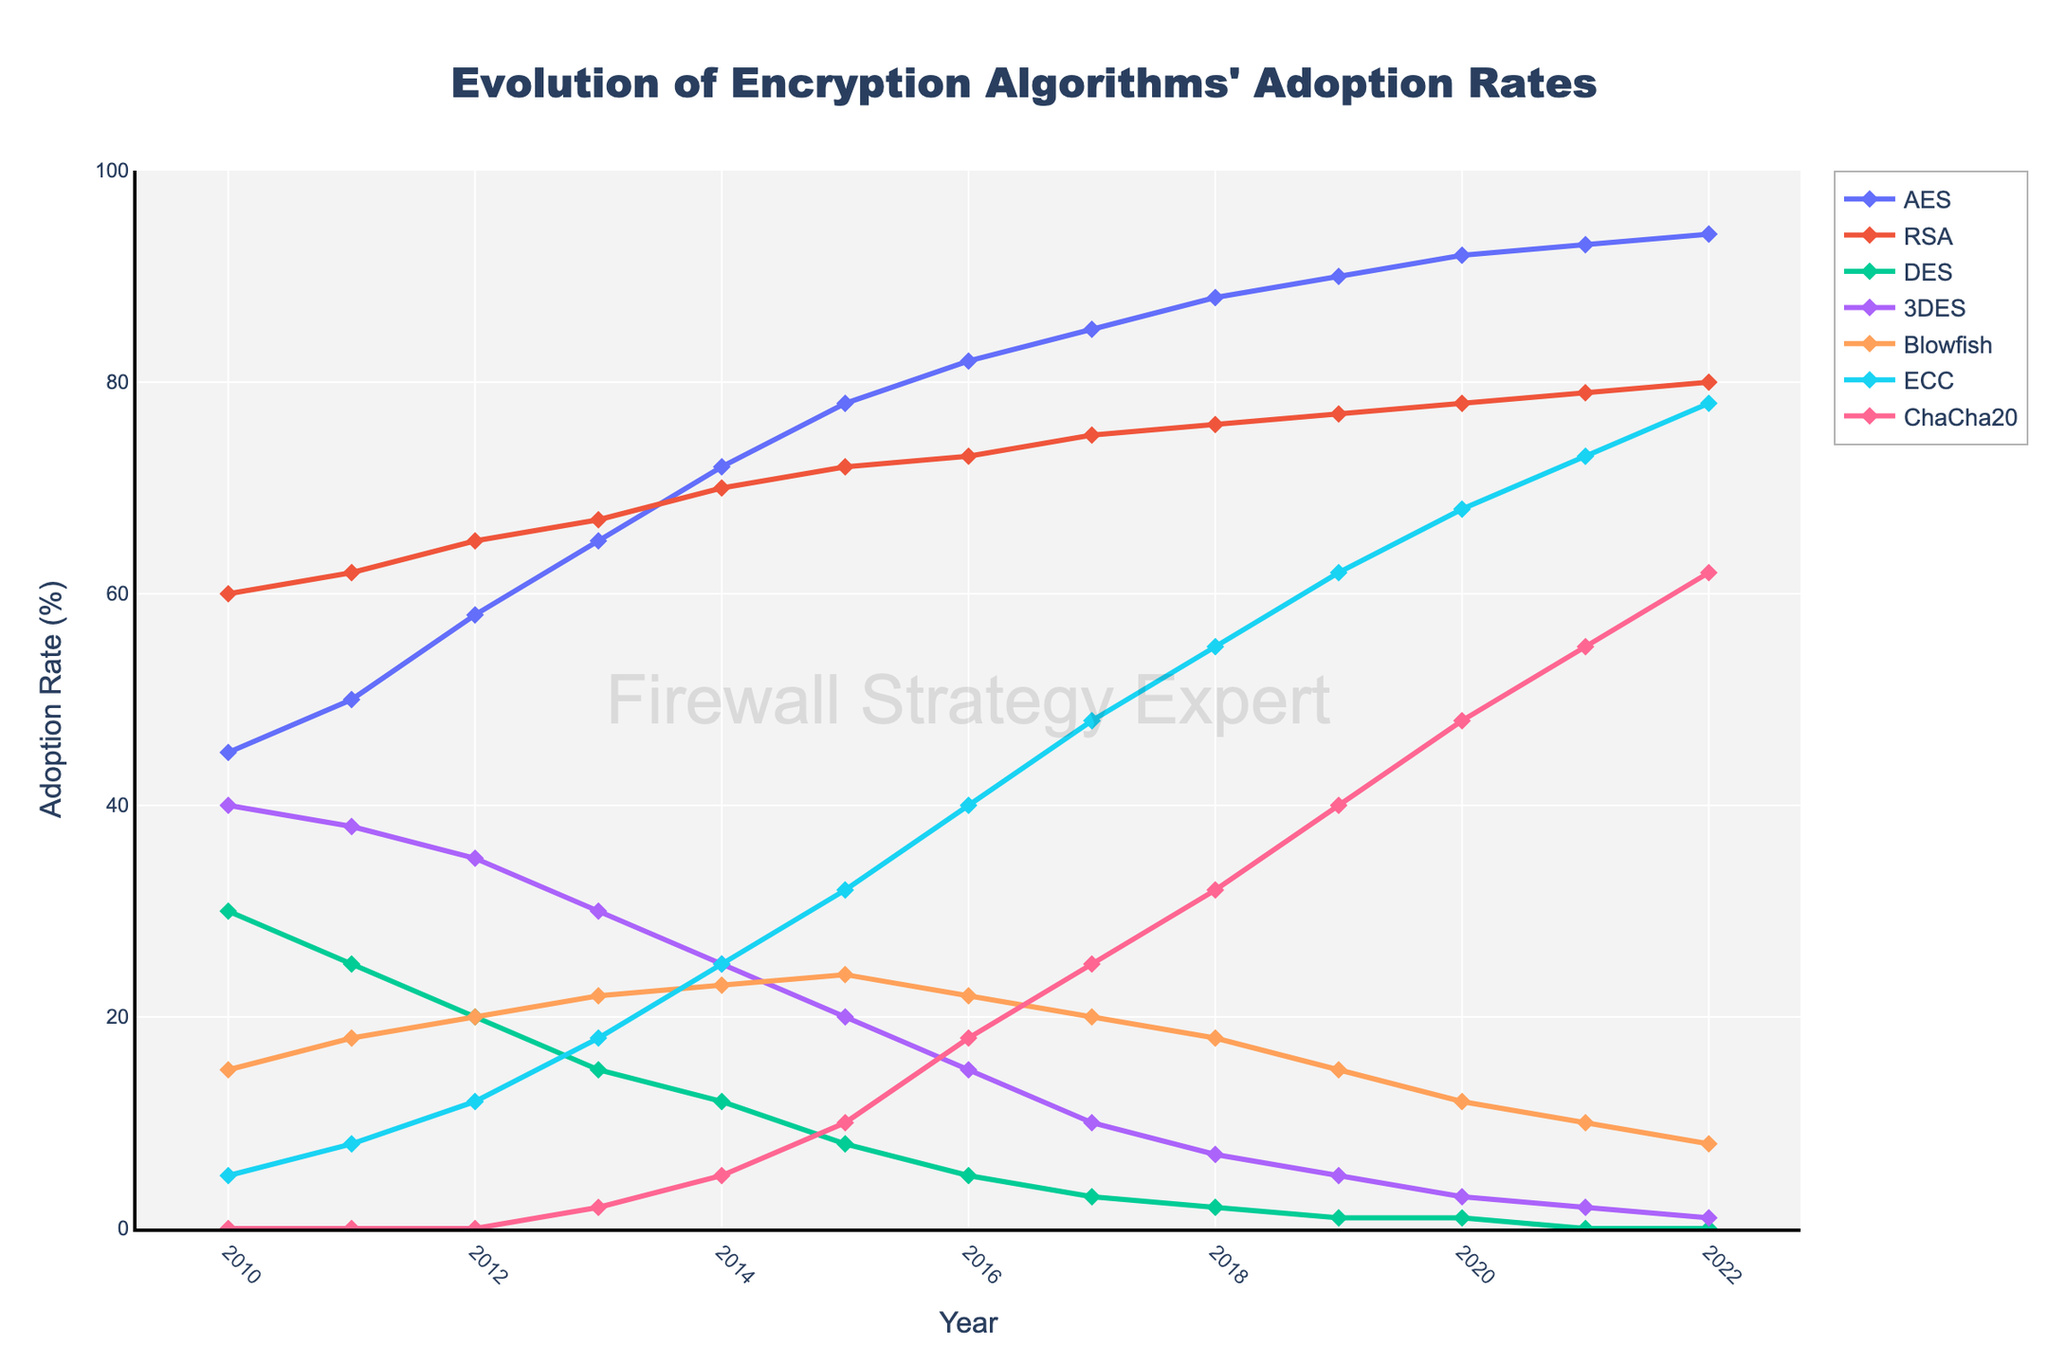How does the adoption rate of AES from 2010 to 2022 compare to RSA? Compare the adoption rates of AES and RSA for each year by observing the visual lines on the graph. The adoption rate of AES starts at 45% in 2010 and increases to 94% by 2022. For RSA, it starts at 60% in 2010 and increases to 80% by 2022.
Answer: AES has seen a larger increase compared to RSA Which encryption algorithm has shown the highest adoption rate by 2022? By looking at the final point (2022) on the graph's y-axis for each algorithm, AES has the highest adoption rate at 94%.
Answer: AES By what percentage did the adoption rate of Blowfish increase from 2010 to 2022? Identify the adoption rate of Blowfish in 2010 (15%) and in 2022 (8%). Calculate the percentage change: (8-15)/15 * 100 = -46.67%.
Answer: -46.67% Between which two consecutive years did ECC see the highest increase in adoption rate? Examine the points of ECC on the graph and compare the differences between consecutive years. The change from 2015 (32%) to 2016 (40%) is the largest with an 8% increase.
Answer: 2015 to 2016 What is the combined adoption rate of ChaCha20 and Blowfish in 2022? Add the adoption rates of ChaCha20 (62%) and Blowfish (8%) in 2022.
Answer: 70% How many times did the adoption rate of DES decrease between 2010 and 2022? Examine the points corresponding to DES on the graph and count the number of times its adoption rate decreases, which happens steadily over the years from 30% in 2010 to 0% in 2022.
Answer: 11 times What is the average adoption rate of ECC over the years 2010 to 2022? Add all the yearly adoption rates of ECC (5, 8, 12, 18, 25, 32, 40, 48, 55, 62, 68, 73, 78) and divide by the number of years (13). The sum is 524, so 524/13 = 40.31%.
Answer: 40.31% Which algorithm had the steepest decline and in which period did it occur? Identify the slope between two points for each algorithm and find the steepest decline. DES had the steepest overall decline from 2010 (30%) to 2022 (0%). The steepest single year decline occurred between 2011 (25%) and 2012 (20%).
Answer: DES, 2011-2012 In which year did ChaCha20 first appear on the graph, and what was its initial adoption rate? ChaCha20 first appears as a visible point on the graph in 2013 with an adoption rate of 2%.
Answer: 2013, 2% What was the difference in adoption rates between 3DES and ECC in 2017? Identify the adoption rates of 3DES (10%) and ECC (48%) in 2017 and find the difference: 48% - 10% = 38%.
Answer: 38% 